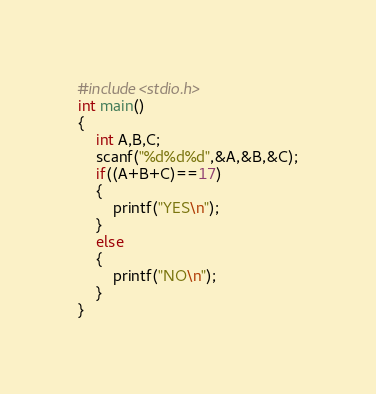<code> <loc_0><loc_0><loc_500><loc_500><_C_>#include<stdio.h>
int main()
{
    int A,B,C;
    scanf("%d%d%d",&A,&B,&C);
    if((A+B+C)==17)
    {
        printf("YES\n");
    }
    else
    {
        printf("NO\n");
    }
}</code> 